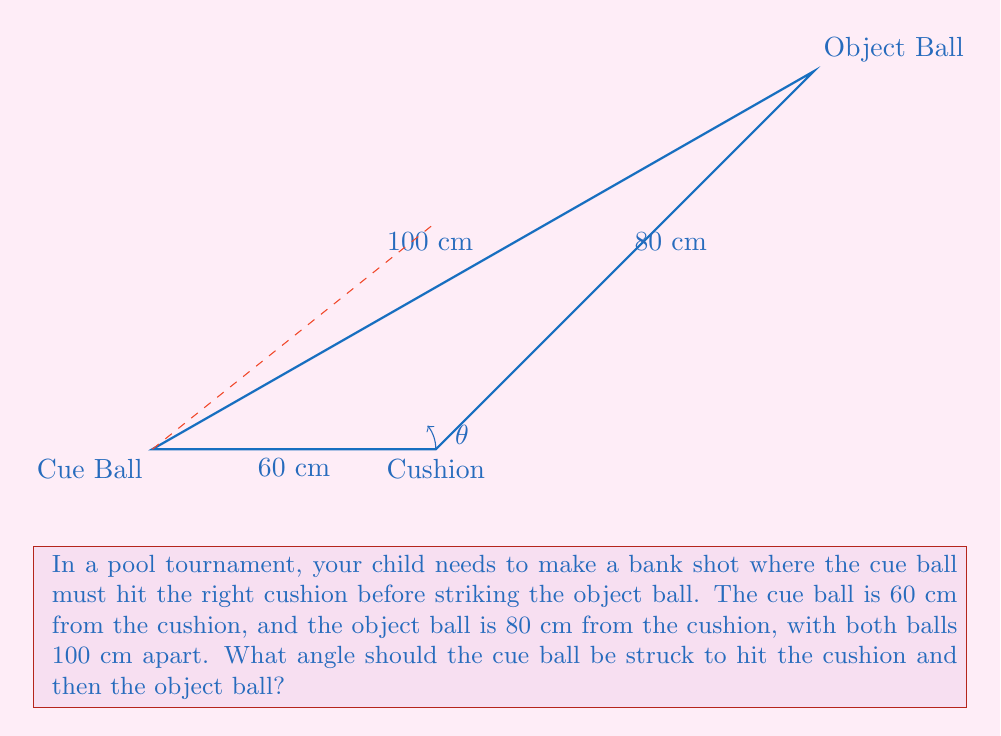Show me your answer to this math problem. Let's approach this step-by-step:

1) First, we need to recognize that this forms a right triangle. The cushion forms the right angle, and we need to find the angle at the cue ball.

2) We can use the tangent function to find this angle. The tangent of an angle is the opposite side divided by the adjacent side.

3) In this case:
   - The opposite side is the distance between where the cue ball hits the cushion and where the object ball is (80 cm).
   - The adjacent side is the distance from the cue ball to the cushion (60 cm).

4) Let's call our angle $\theta$. We can set up the equation:

   $$\tan(\theta) = \frac{\text{opposite}}{\text{adjacent}} = \frac{80}{60} = \frac{4}{3}$$

5) To find $\theta$, we need to take the inverse tangent (arctan or $\tan^{-1}$) of both sides:

   $$\theta = \tan^{-1}(\frac{4}{3})$$

6) Using a calculator or computer, we can calculate this:

   $$\theta \approx 53.13^\circ$$

7) However, this is not the angle we want. This is the angle between the path of the cue ball and the cushion. We need the angle between the path of the cue ball and the line perpendicular to the cushion.

8) To get this, we subtract our calculated angle from 90°:

   $$90^\circ - 53.13^\circ \approx 36.87^\circ$$

This is the angle at which the cue ball should be struck.
Answer: $36.87^\circ$ 